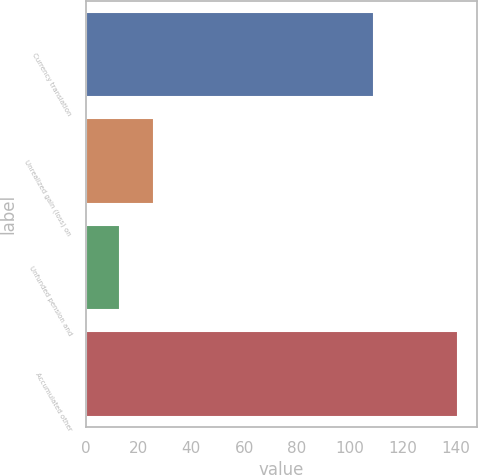<chart> <loc_0><loc_0><loc_500><loc_500><bar_chart><fcel>Currency translation<fcel>Unrealized gain (loss) on<fcel>Unfunded pension and<fcel>Accumulated other<nl><fcel>109<fcel>25.8<fcel>13<fcel>141<nl></chart> 